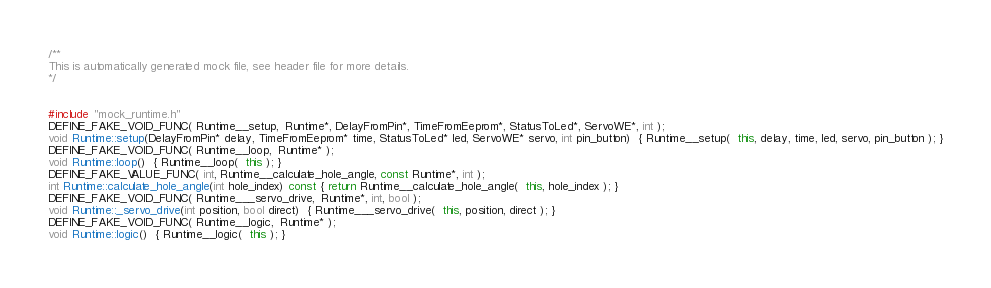Convert code to text. <code><loc_0><loc_0><loc_500><loc_500><_C++_>
/**
This is automatically generated mock file, see header file for more details.
*/


#include "mock_runtime.h"
DEFINE_FAKE_VOID_FUNC( Runtime__setup,  Runtime*, DelayFromPin*, TimeFromEeprom*, StatusToLed*, ServoWE*, int );
void Runtime::setup(DelayFromPin* delay, TimeFromEeprom* time, StatusToLed* led, ServoWE* servo, int pin_button)  { Runtime__setup(  this, delay, time, led, servo, pin_button ); }
DEFINE_FAKE_VOID_FUNC( Runtime__loop,  Runtime* );
void Runtime::loop()  { Runtime__loop(  this ); }
DEFINE_FAKE_VALUE_FUNC( int, Runtime__calculate_hole_angle, const Runtime*, int );
int Runtime::calculate_hole_angle(int hole_index) const { return Runtime__calculate_hole_angle(  this, hole_index ); }
DEFINE_FAKE_VOID_FUNC( Runtime___servo_drive,  Runtime*, int, bool );
void Runtime::_servo_drive(int position, bool direct)  { Runtime___servo_drive(  this, position, direct ); }
DEFINE_FAKE_VOID_FUNC( Runtime__logic,  Runtime* );
void Runtime::logic()  { Runtime__logic(  this ); }
</code> 